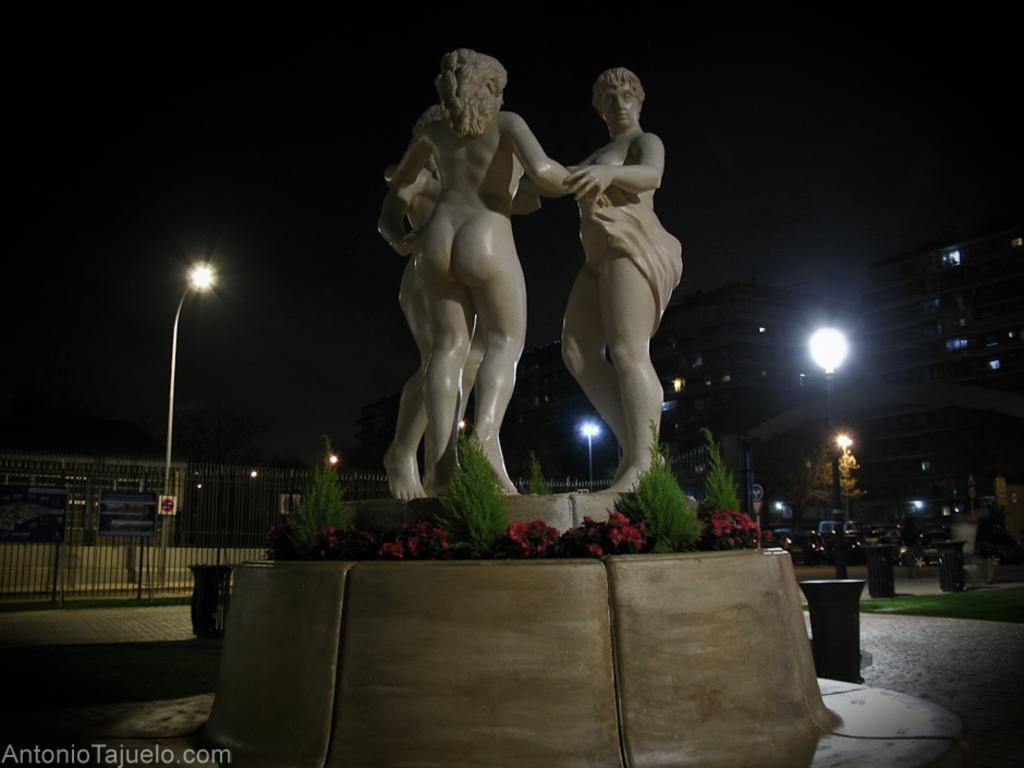In one or two sentences, can you explain what this image depicts? In the foreground we can see plants, sculpture and pavement. In the middle we can see trees, street lights, fencing, vehicles, dustbin, grass and various objects. Towards right we can see buildings. At the top there is sky. 